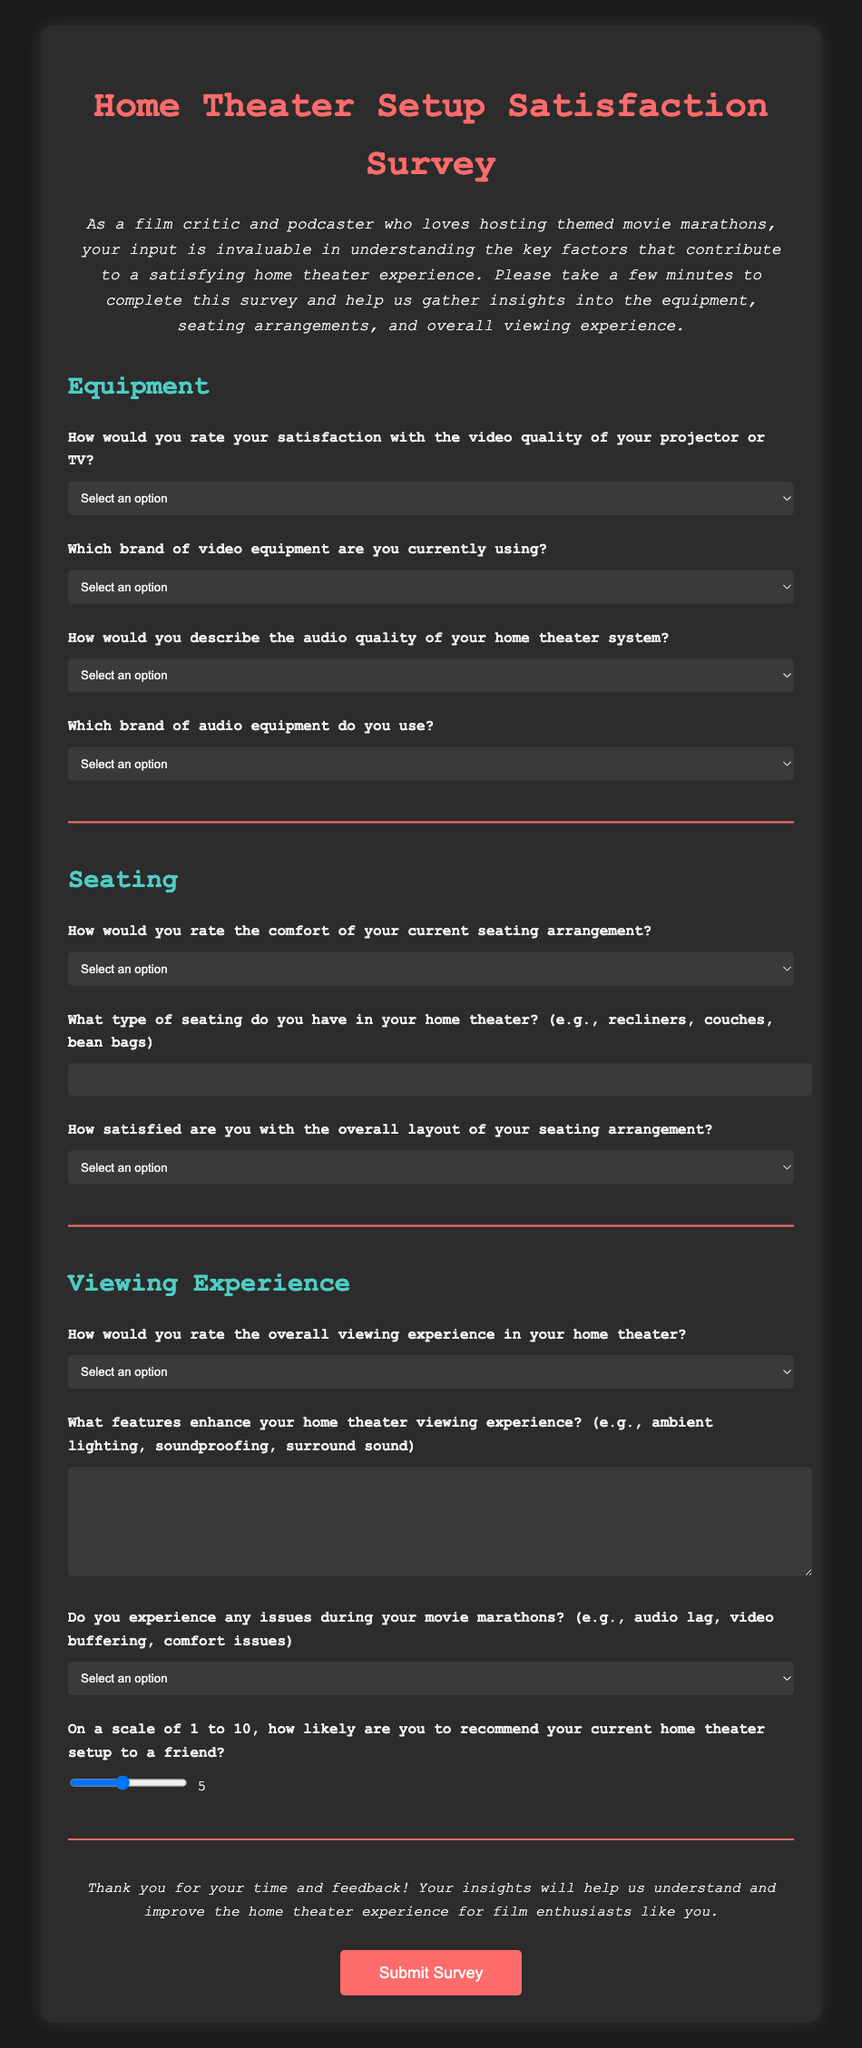What is the title of the survey? The title of the survey is prominently displayed at the top of the document.
Answer: Home Theater Setup Satisfaction Survey How many sections are in the survey? The survey is divided into three main sections.
Answer: Three What is the first question regarding equipment? The first question in the Equipment section pertains to video quality.
Answer: How would you rate your satisfaction with the video quality of your projector or TV? Which audio brand options are provided in the survey? The survey lists various brands of audio equipment for selection.
Answer: Bose, Sonos, Yamaha, Klipsch, Sony, Other How is the recommendation to friends measured? The survey asks respondents to use a scale for their recommendation.
Answer: On a scale of 1 to 10 What comfort rating is the survey asking for regarding seating? The survey asks respondents to evaluate comfort levels for seating arrangements.
Answer: How would you rate the comfort of your current seating arrangement? What type of input field is used for describing seating type? The document specifies what kind of input is required for the seating type query.
Answer: Text input What is the closing statement of the survey? The closing statement expresses gratitude for the participants' feedback.
Answer: Thank you for your time and feedback! 